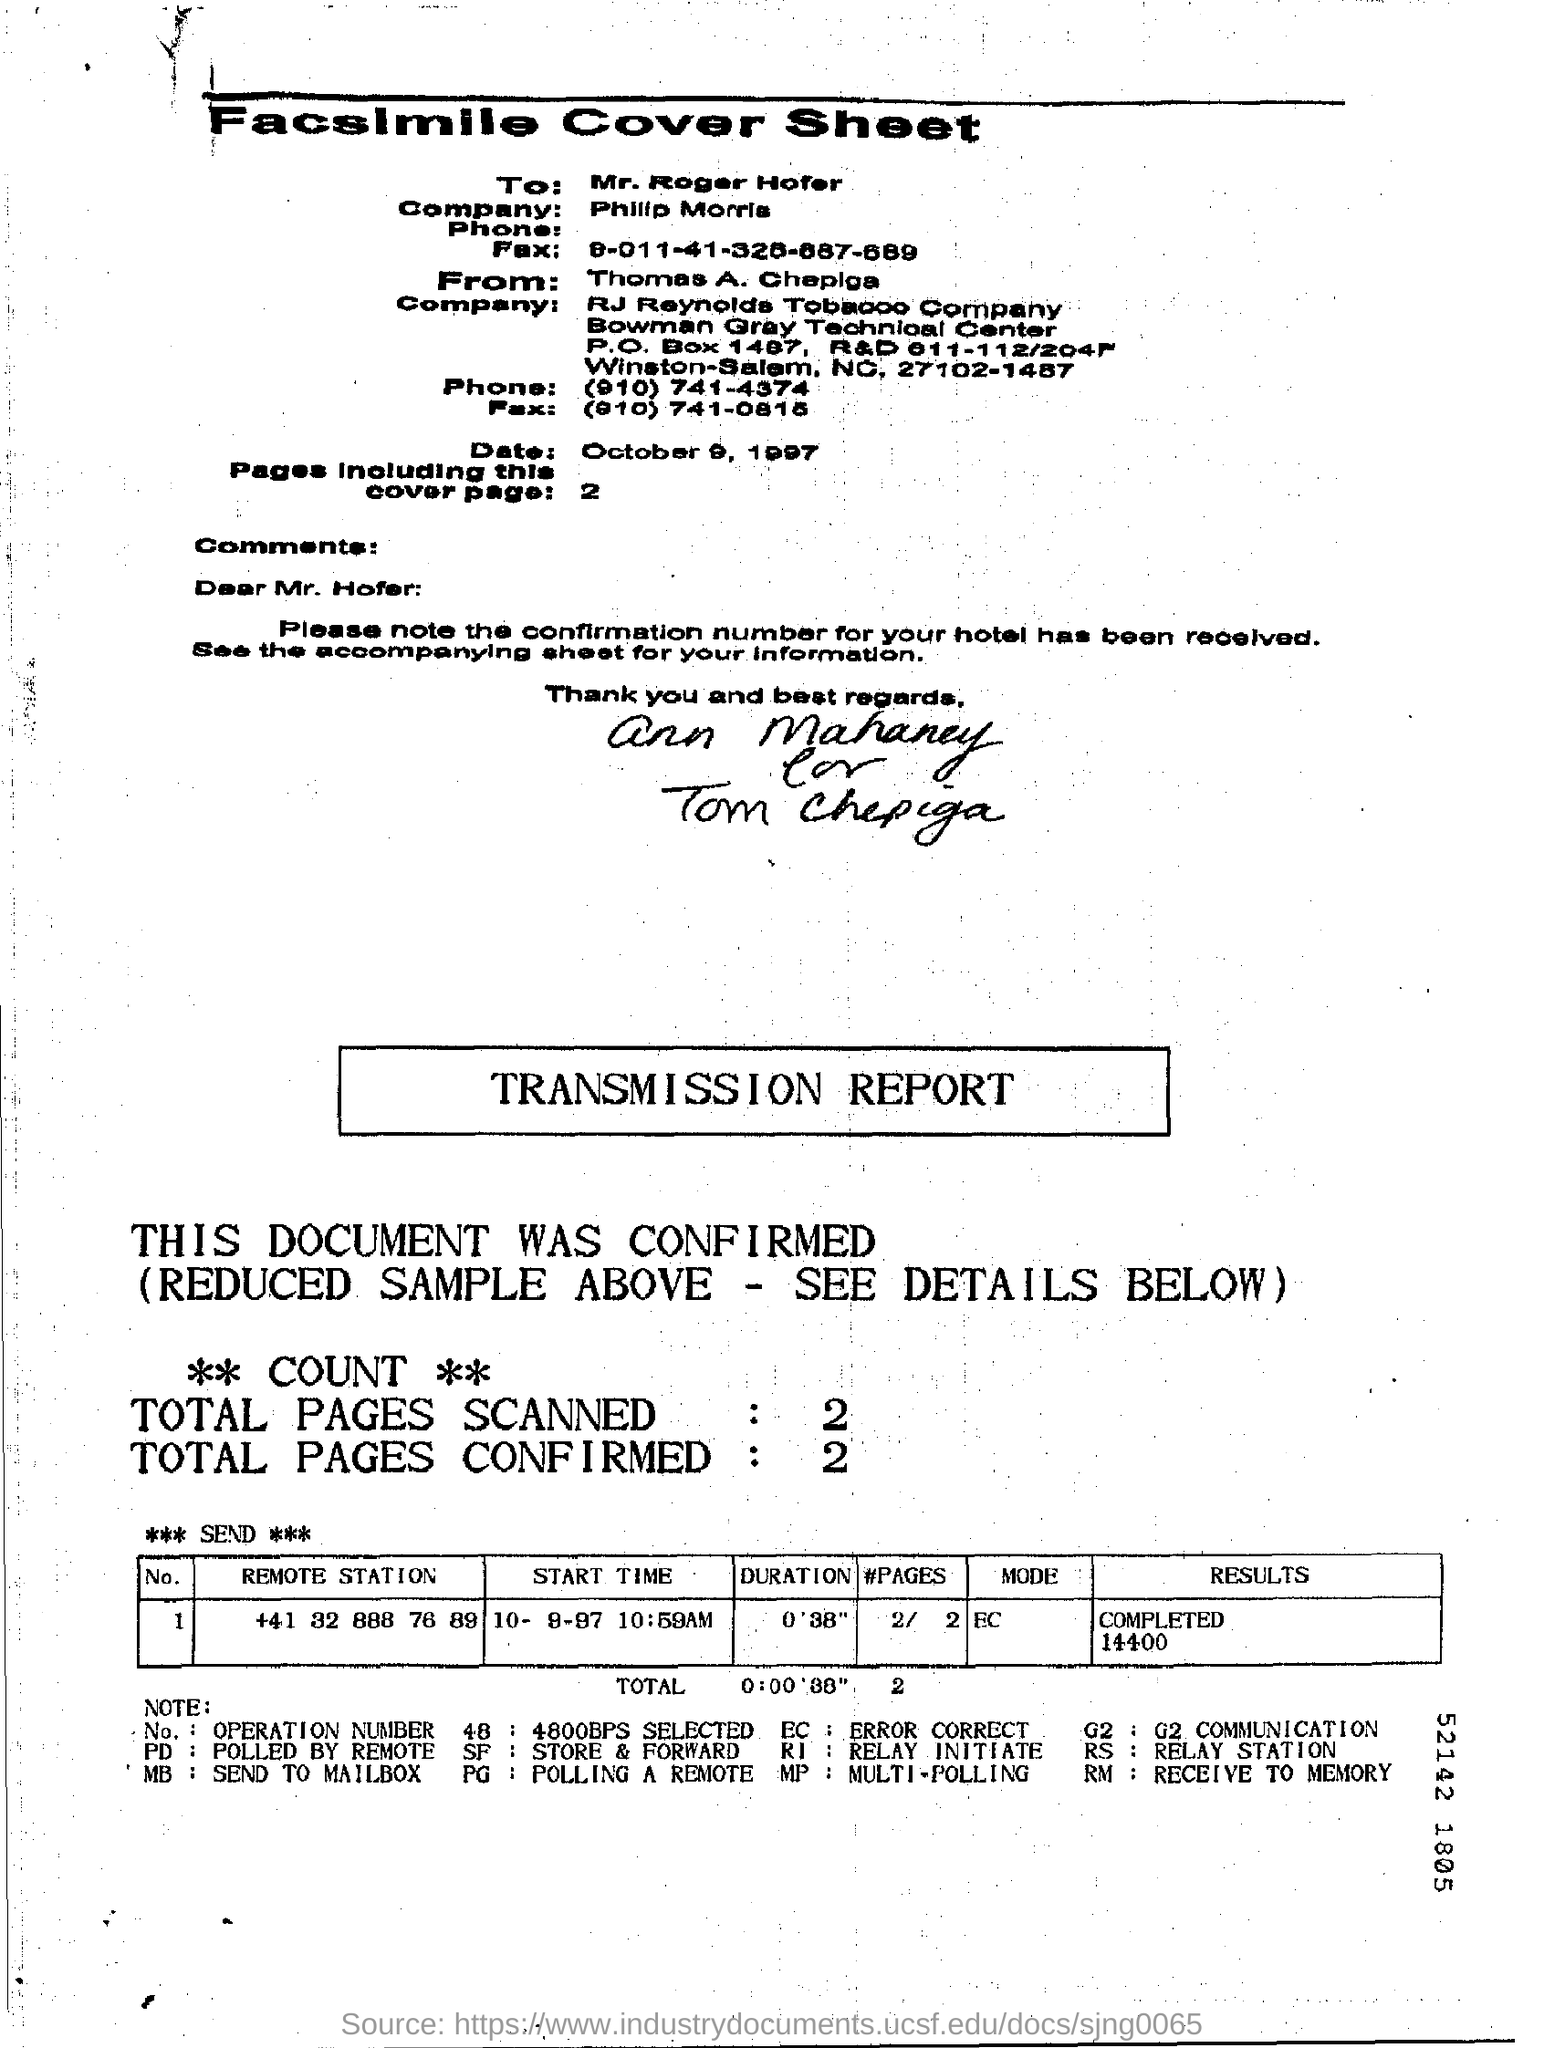Give some essential details in this illustration. The total number of pages scanned was 2.. The company of Mr. Roger Hofer is named Philip Morris. The date mentioned in the top half of the document is October 9, 1997. 